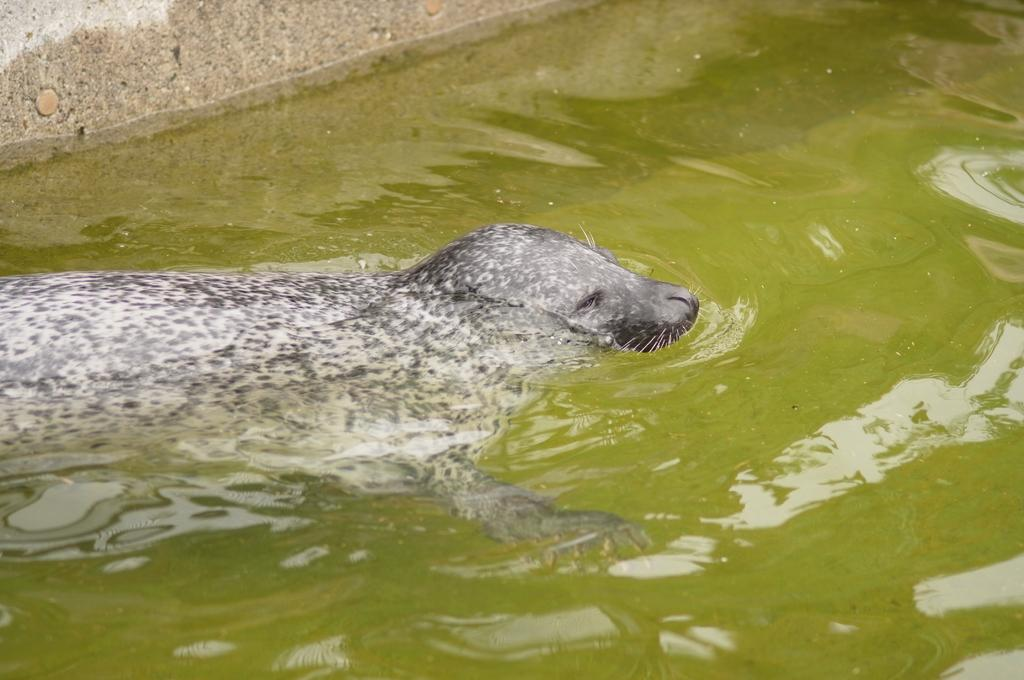What animal can be seen in the water in the image? There is a seal in the water in the image. What structure is visible in the image? There is a wall visible in the image. Reasoning: Let' Let's think step by step in order to produce the conversation. We start by identifying the main subject in the image, which is the seal in the water. Then, we expand the conversation to include the other visible structure, which is the wall. Each question is designed to elicit a specific detail about the image that is known from the provided facts. Absurd Question/Answer: What type of powder can be seen falling from the seal's ear in the image? There is no powder or ear visible in the image, as it features a seal in the water and a wall. 